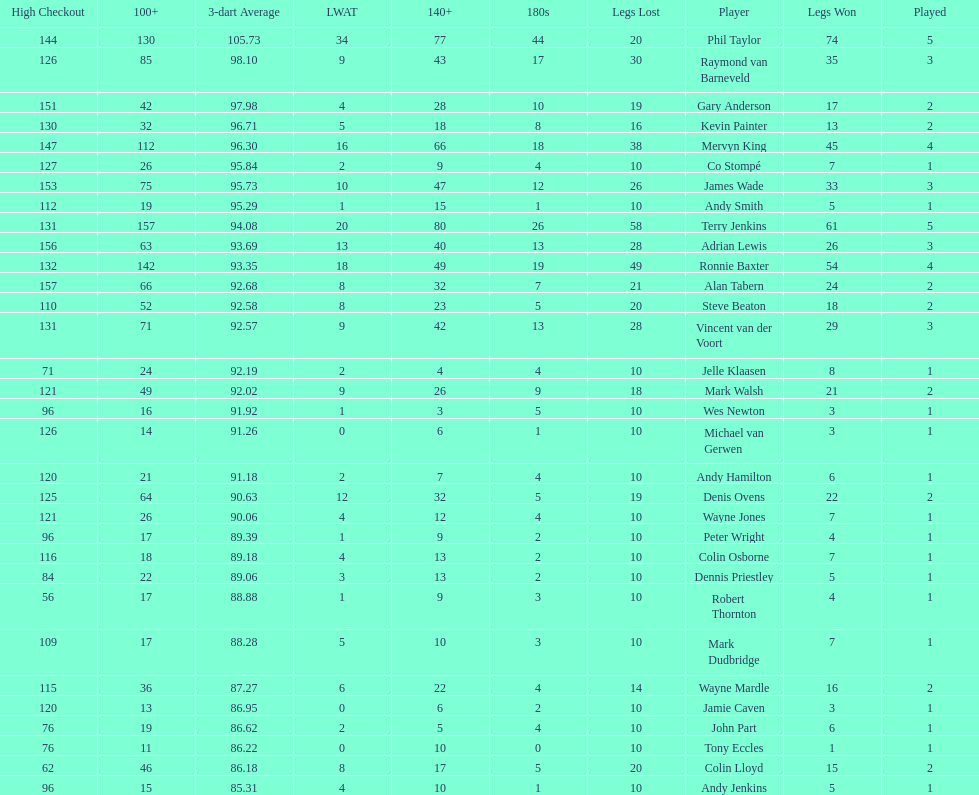How many players have a 3 dart average of more than 97? 3. 